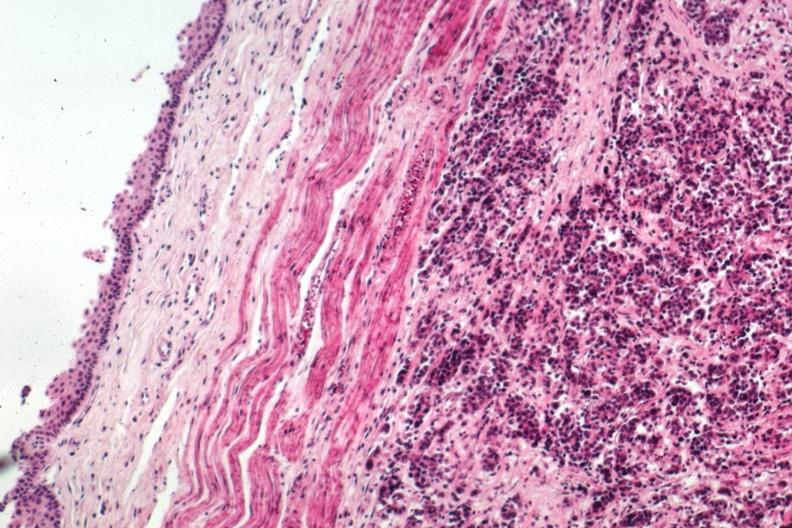s macerated stillborn present?
Answer the question using a single word or phrase. No 